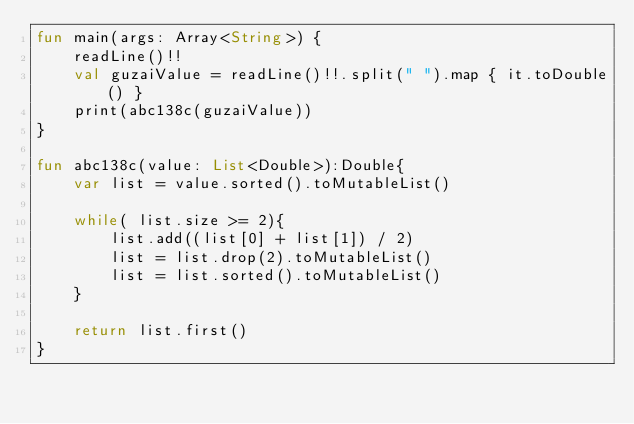<code> <loc_0><loc_0><loc_500><loc_500><_Kotlin_>fun main(args: Array<String>) {
    readLine()!!
    val guzaiValue = readLine()!!.split(" ").map { it.toDouble() }
    print(abc138c(guzaiValue))
}

fun abc138c(value: List<Double>):Double{
    var list = value.sorted().toMutableList()

    while( list.size >= 2){
        list.add((list[0] + list[1]) / 2)
        list = list.drop(2).toMutableList()
        list = list.sorted().toMutableList()
    }

    return list.first()
}</code> 